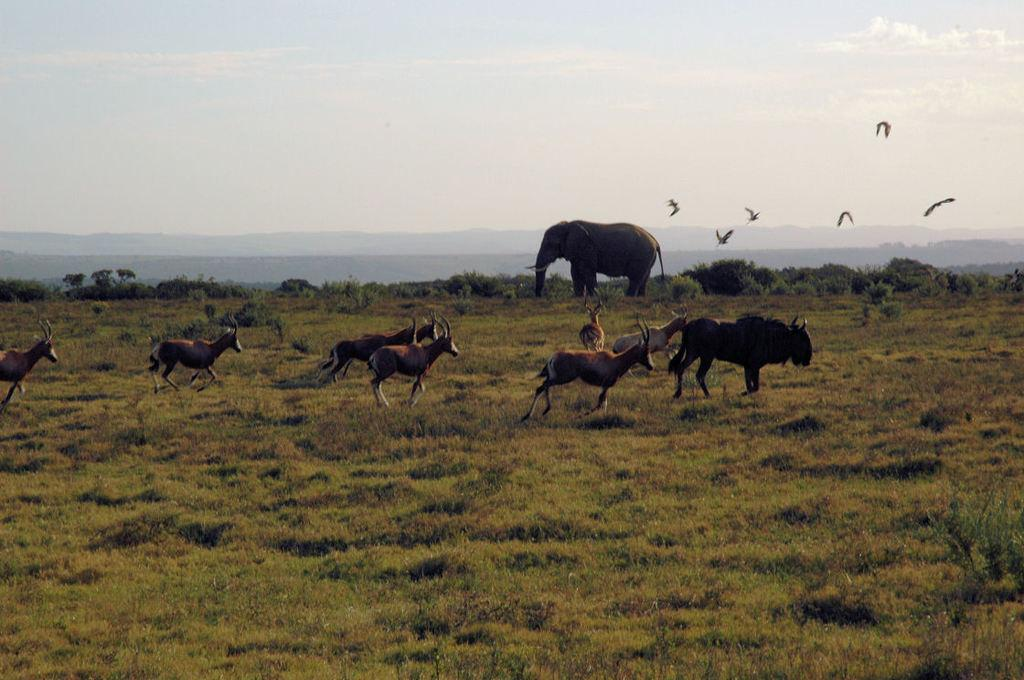What is located in the center of the image? There are animals in the center of the image. What can be seen in the background of the image? There are mountains, birds, and an elephant in the background of the image. What is the color of the sky in the image? The sky is visible in the background of the image. What type of terrain is at the bottom of the image? There is grass at the bottom of the image. What type of needle is being used by the doll in the image? There is no doll or needle present in the image. How does the society depicted in the image interact with the animals? There is no society depicted in the image; it features animals, mountains, birds, an elephant, the sky, and grass. 